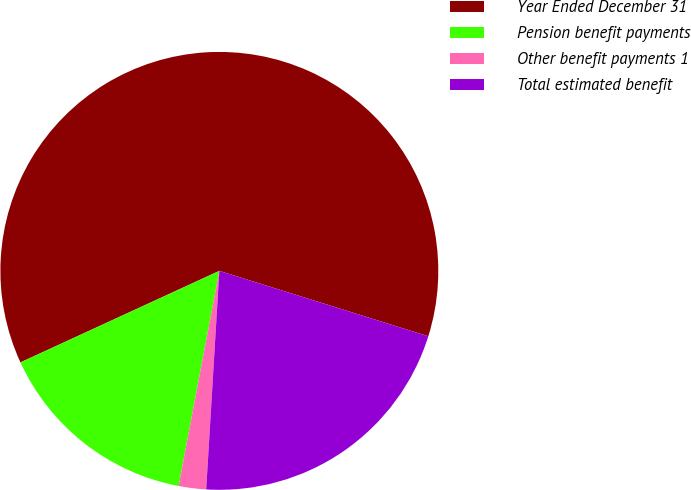Convert chart to OTSL. <chart><loc_0><loc_0><loc_500><loc_500><pie_chart><fcel>Year Ended December 31<fcel>Pension benefit payments<fcel>Other benefit payments 1<fcel>Total estimated benefit<nl><fcel>61.69%<fcel>15.16%<fcel>2.02%<fcel>21.13%<nl></chart> 